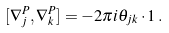<formula> <loc_0><loc_0><loc_500><loc_500>[ \nabla ^ { P } _ { j } , \nabla _ { k } ^ { P } ] = - 2 \pi i \theta _ { j k } \cdot { 1 } \, .</formula> 